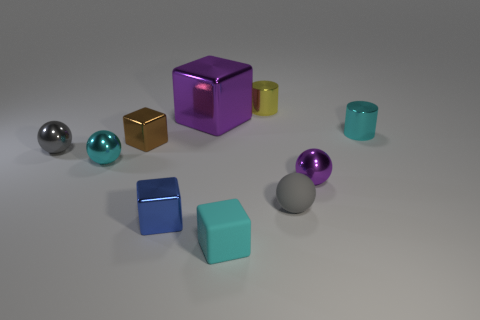What is the size of the rubber thing that is to the left of the small rubber thing that is behind the cyan cube?
Offer a terse response. Small. There is a purple sphere to the right of the gray rubber thing; does it have the same size as the small cyan cylinder?
Make the answer very short. Yes. Is the number of blue objects that are left of the small purple metallic ball greater than the number of purple blocks right of the cyan block?
Keep it short and to the point. Yes. There is a thing that is both left of the large purple metal block and behind the small gray metal object; what is its shape?
Ensure brevity in your answer.  Cube. There is a matte thing that is to the left of the yellow metallic cylinder; what shape is it?
Provide a short and direct response. Cube. There is a metal cube on the right side of the tiny shiny cube that is in front of the small cyan shiny object that is in front of the small brown object; how big is it?
Give a very brief answer. Large. Does the tiny cyan matte thing have the same shape as the tiny brown object?
Give a very brief answer. Yes. How big is the metallic object that is both on the right side of the blue shiny block and left of the tiny yellow shiny cylinder?
Make the answer very short. Large. What is the material of the blue object that is the same shape as the small cyan matte object?
Provide a short and direct response. Metal. What material is the gray ball that is behind the gray thing that is right of the gray shiny ball?
Your answer should be compact. Metal. 